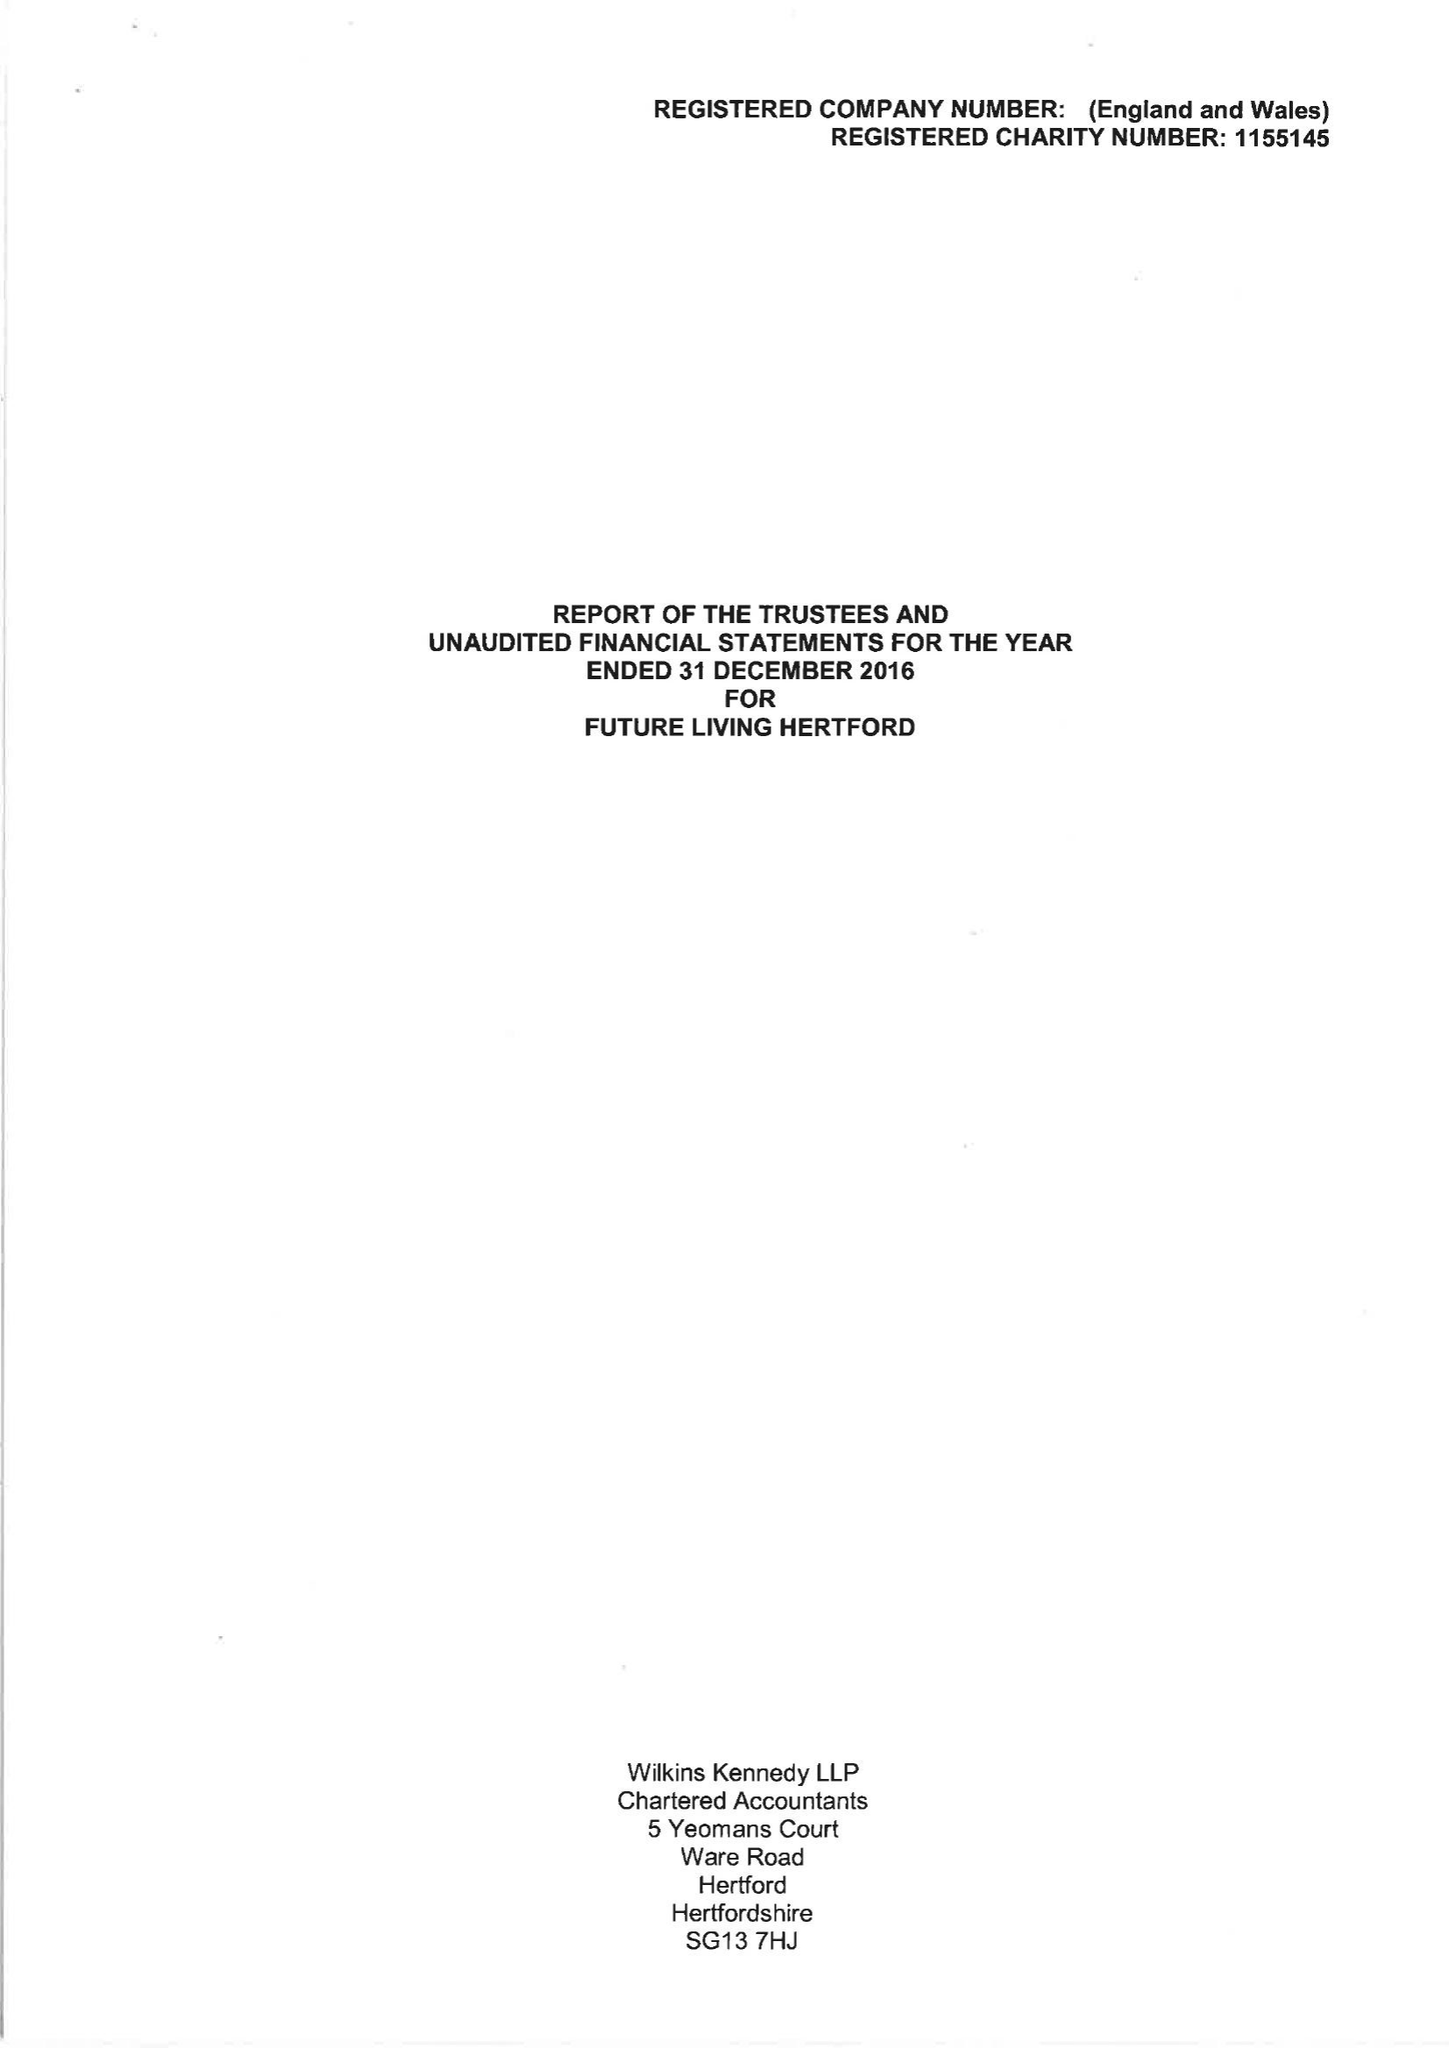What is the value for the income_annually_in_british_pounds?
Answer the question using a single word or phrase. 71638.00 